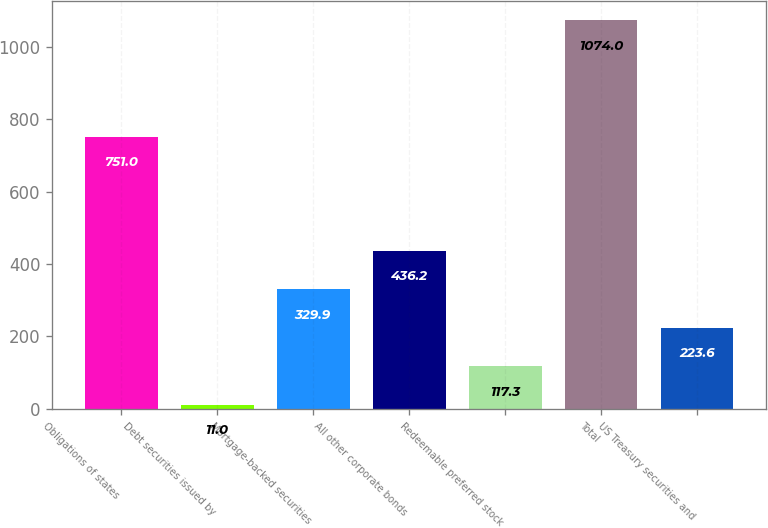Convert chart. <chart><loc_0><loc_0><loc_500><loc_500><bar_chart><fcel>Obligations of states<fcel>Debt securities issued by<fcel>Mortgage-backed securities<fcel>All other corporate bonds<fcel>Redeemable preferred stock<fcel>Total<fcel>US Treasury securities and<nl><fcel>751<fcel>11<fcel>329.9<fcel>436.2<fcel>117.3<fcel>1074<fcel>223.6<nl></chart> 